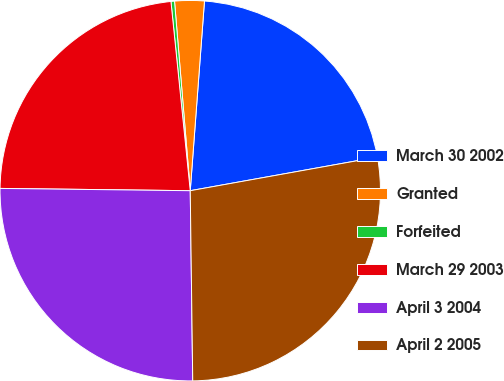Convert chart to OTSL. <chart><loc_0><loc_0><loc_500><loc_500><pie_chart><fcel>March 30 2002<fcel>Granted<fcel>Forfeited<fcel>March 29 2003<fcel>April 3 2004<fcel>April 2 2005<nl><fcel>20.98%<fcel>2.51%<fcel>0.3%<fcel>23.19%<fcel>25.4%<fcel>27.62%<nl></chart> 